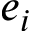<formula> <loc_0><loc_0><loc_500><loc_500>e _ { i }</formula> 